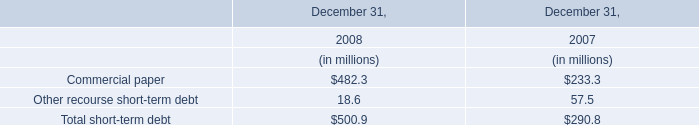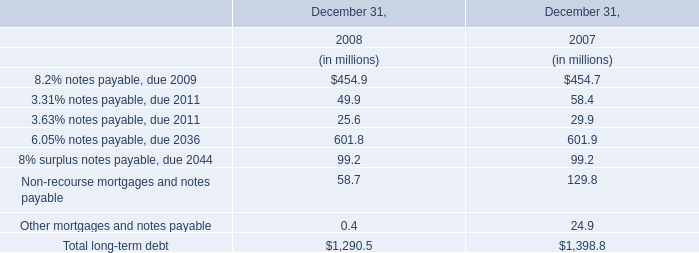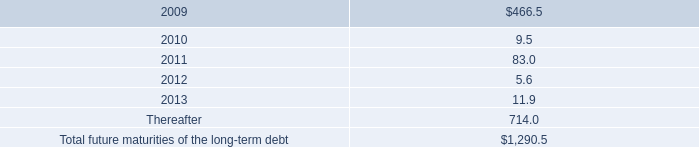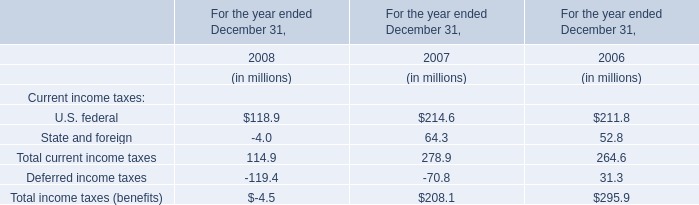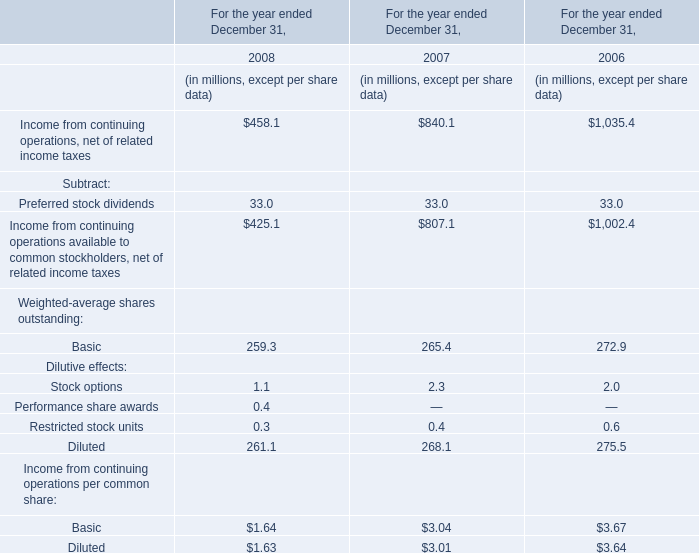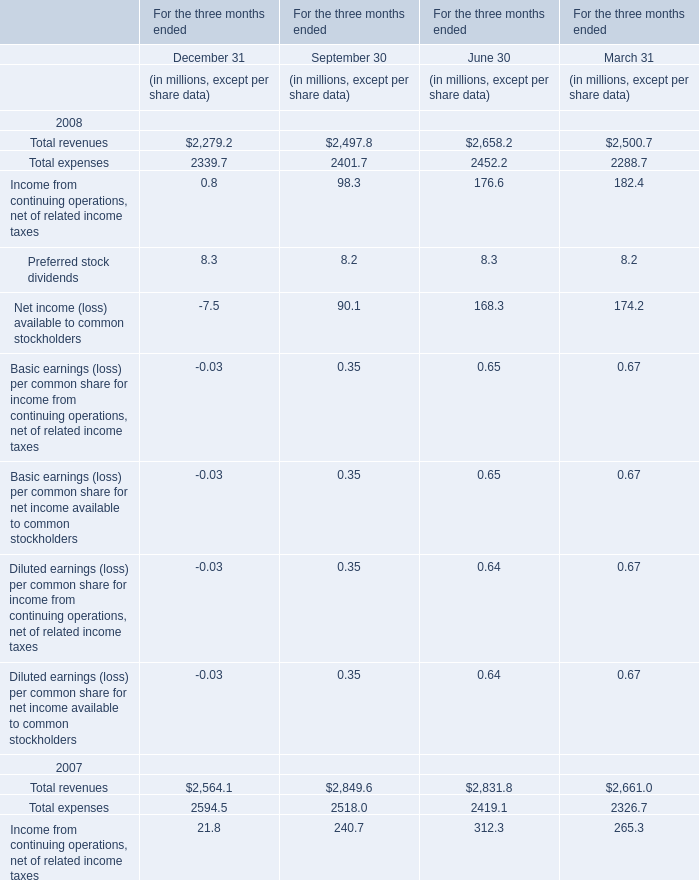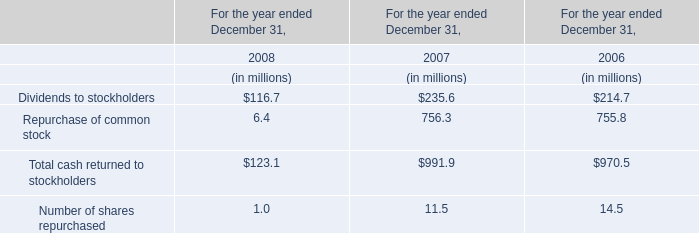When is Income from continuing operations, net of related income taxes the largest? 
Answer: 2006. 